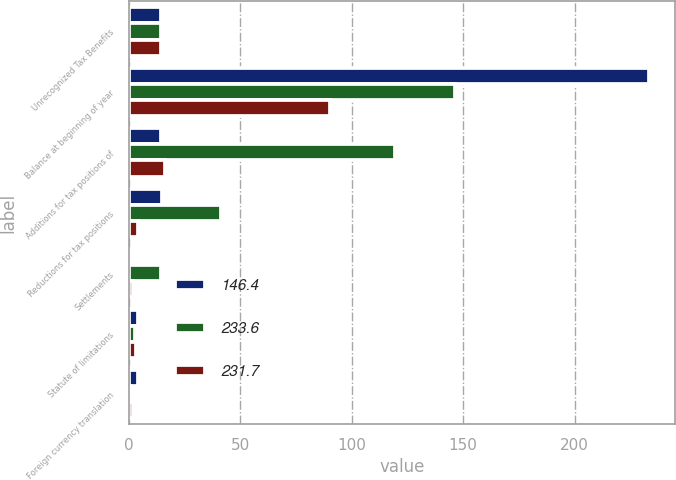Convert chart. <chart><loc_0><loc_0><loc_500><loc_500><stacked_bar_chart><ecel><fcel>Unrecognized Tax Benefits<fcel>Balance at beginning of year<fcel>Additions for tax positions of<fcel>Reductions for tax positions<fcel>Settlements<fcel>Statute of limitations<fcel>Foreign currency translation<nl><fcel>146.4<fcel>14.2<fcel>233.6<fcel>14.2<fcel>14.7<fcel>1.5<fcel>3.9<fcel>3.8<nl><fcel>233.6<fcel>14.2<fcel>146.4<fcel>119.2<fcel>41.3<fcel>14.2<fcel>2.6<fcel>0.3<nl><fcel>231.7<fcel>14.2<fcel>90.2<fcel>16.1<fcel>4<fcel>2<fcel>3.2<fcel>1.8<nl></chart> 